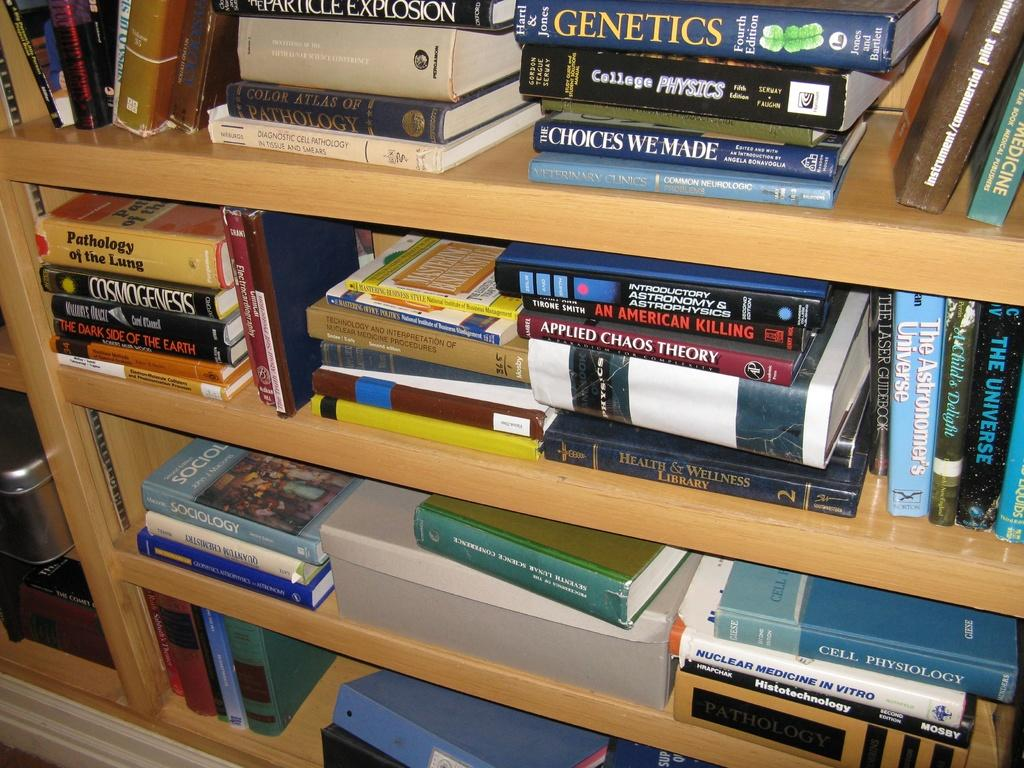Provide a one-sentence caption for the provided image. Several books on genetics are stacked on shelves. 